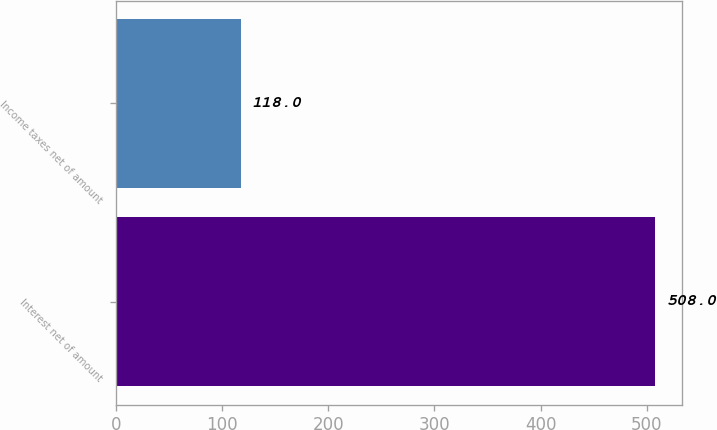<chart> <loc_0><loc_0><loc_500><loc_500><bar_chart><fcel>Interest net of amount<fcel>Income taxes net of amount<nl><fcel>508<fcel>118<nl></chart> 